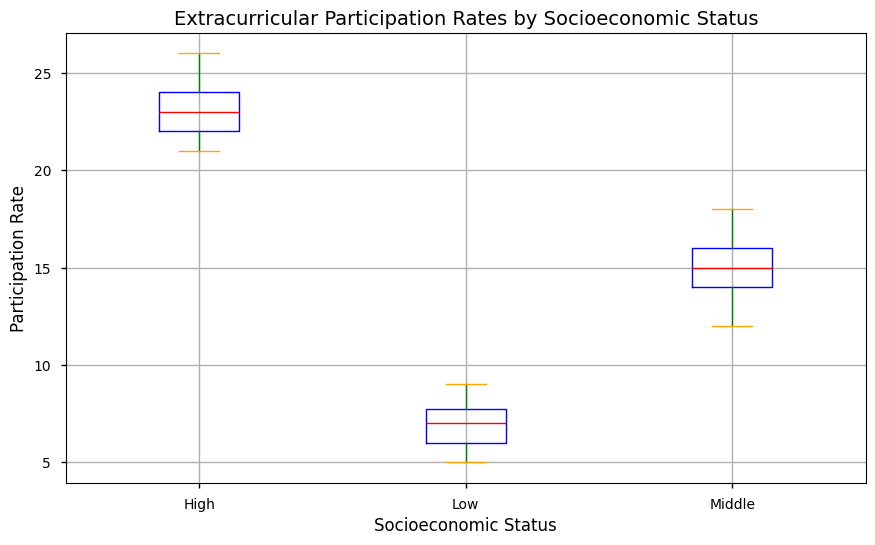What is the median participation rate for each socioeconomic status group? The median is the middle value when the data is ordered. For the Low group, the ordered values are [5, 5, 6, 6, 7, 7, 7, 8, 8, 9], so the median is (7+7)/2 = 7. For the Middle group, the ordered values are [12, 13, 14, 14, 15, 15, 16, 16, 17, 18], so the median is (15+15)/2 = 15. For the High group, the ordered values are [21, 21, 22, 22, 23, 23, 24, 24, 25, 26], so the median is (23+23)/2 = 23.
Answer: Low: 7, Middle: 15, High: 23 Which socioeconomic status group has the highest maximum participation rate? The maximum rate is the highest value in each group. For Low it is 9, for Middle it is 18, and for High it is 26. So, the High group has the highest maximum participation rate.
Answer: High What is the interquartile range (IQR) for the Middle socioeconomic status group? The IQR is the difference between the third quartile (Q3) and the first quartile (Q1). For the Middle group, Q1 is the median of the first half [12, 13, 14, 14, 15], which is 14, and Q3 is the median of the second half [15, 16, 16, 17, 18], which is 16. So, the IQR is 16 - 14 = 2.
Answer: 2 Which socioeconomic status group has the smallest range of participation rates? The range is the difference between the maximum and minimum values. For Low, it is 9 - 5 = 4; for Middle, it is 18 - 12 = 6; and for High, it is 26 - 21 = 5. The Low group has the smallest range of 4.
Answer: Low Compare the median and interquartile range (IQR) of the Low and High socioeconomic status groups. Which group shows more variability? The median of Low is 7, and IQR is 2 (Q3=8 and Q1=6). The median of High is 23, and IQR is 3 (Q3=24 and Q1=21). As the IQR represents the middle 50% of the data, a higher IQR in the High group indicates more variability compared to the Low group.
Answer: High Are there any outliers visible in the plot? Outliers are typically represented by individual points outside the whiskers. If no points are separately marked outside the whiskers in any of the groups, then there are no outliers.
Answer: No How does the median participation rate of the Middle group compare to the maximum participation rate of the Low group? The median of the Middle group is 15, and the maximum of the Low group is 9. Comparing these, the median of the Middle group is higher than the maximum of the Low group.
Answer: Median of Middle > Maximum of Low Explaining how the middle 50% of participation rates for the High group compare with those for the Low group. The middle 50% is described by the IQR. For High, Q1 is 21 and Q3 is 24, so the middle 50% ranges from 21 to 24. For Low, Q1 is 6 and Q3 is 8, so the middle 50% ranges from 6 to 8. The middle 50% for High is higher in value compared to Low.
Answer: Higher for High 